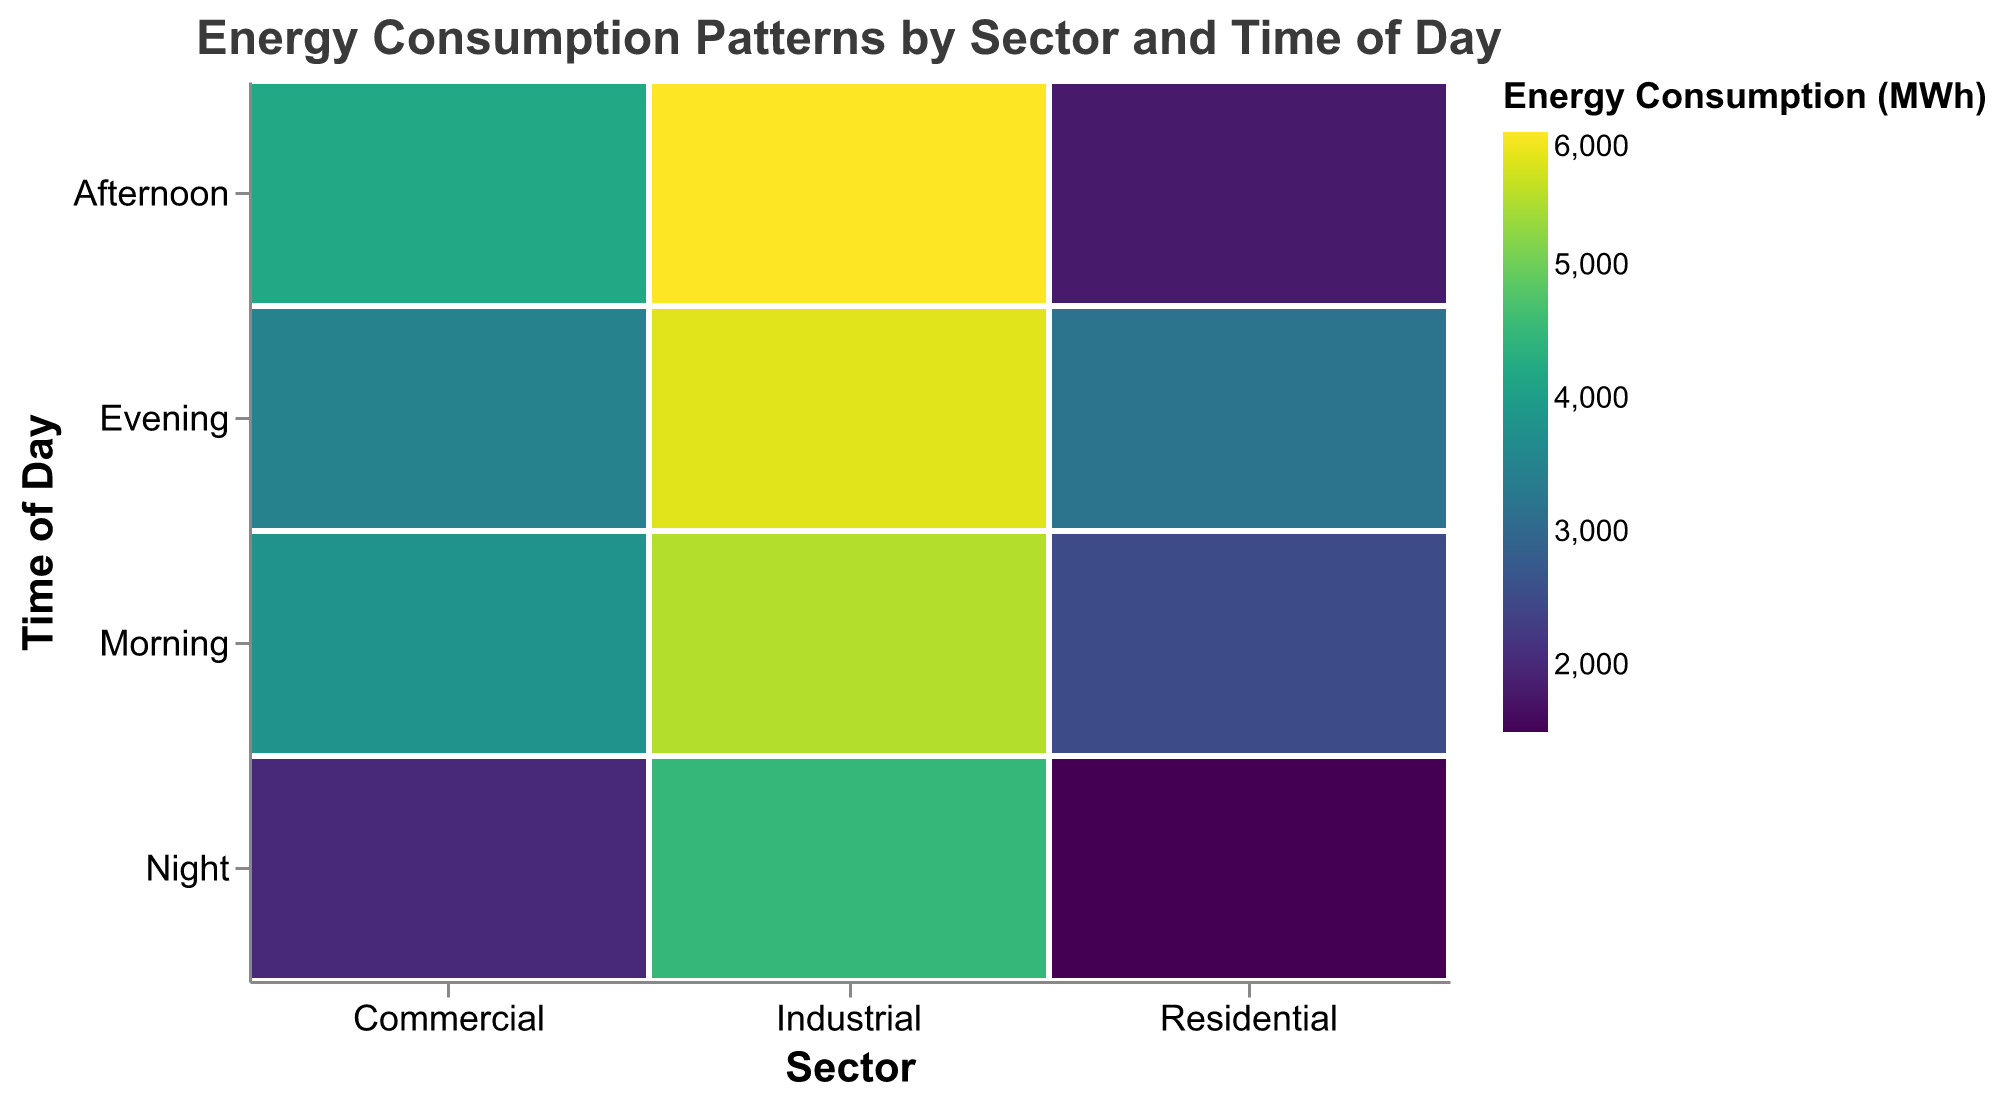What is the title of the plot? The title is located at the top of the plot, and it reads "Energy Consumption Patterns by Sector and Time of Day."
Answer: Energy Consumption Patterns by Sector and Time of Day Which sector has the highest energy consumption in the morning? By examining the color intensity for the morning time of day, the industrial sector has the darkest shade, indicating the highest energy consumption.
Answer: Industrial How much energy is consumed by the Commercial sector in the afternoon? Locate the commercial sector, then the afternoon time of day. The figure shows that energy consumption is marked as 4200 MWh.
Answer: 4200 MWh What is the total energy consumption for the Residential sector? Sum the energy consumption values for each time of day in the Residential sector: 2500 (Morning) + 1800 (Afternoon) + 3200 (Evening) + 1500 (Night) = 9000 MWh.
Answer: 9000 MWh Which time of day has the lowest energy consumption for the Industrial sector? By observing the lighter shades for the Industrial sector, the Night has the lightest shade, indicating the lowest consumption of 4500 MWh.
Answer: Night Compare the energy consumption between the Commercial and Residential sectors in the Evening. Check the colors corresponding to the Evening for both sectors: Residential has 3200 MWh, and Commercial has 3500 MWh, so Commercial is higher.
Answer: Commercial In which sector and time of day does the maximum energy consumption occur? The darkest shade in the plot represents the highest consumption, found in the Industrial sector during the Afternoon with 6000 MWh.
Answer: Industrial, Afternoon How much more energy is consumed by the Industrial sector in the Evening compared to the Night? Subtract the energy consumption of Night from Evening for Industrial sector: 5800 MWh (Evening) - 4500 MWh (Night) = 1300 MWh.
Answer: 1300 MWh What are the energy consumption differences between Morning and Afternoon for each sector? Calculate the differences for each sector: Residential: 2500 - 1800 = 700 MWh, Commercial: 4200 - 3800 = 400 MWh, Industrial: 6000 - 5500 = 500 MWh.
Answer: Residential: 700 MWh, Commercial: 400 MWh, Industrial: 500 MWh Is there any time of day where the energy consumption for all sectors is less than 5000 MWh? Scan all sectors and times of the day to check for values below 5000 MWh. The Night period for Residential (1500 MWh), Commercial (2000 MWh), and Industrial (4500 MWh) all fall below 5000 MWh.
Answer: Night 